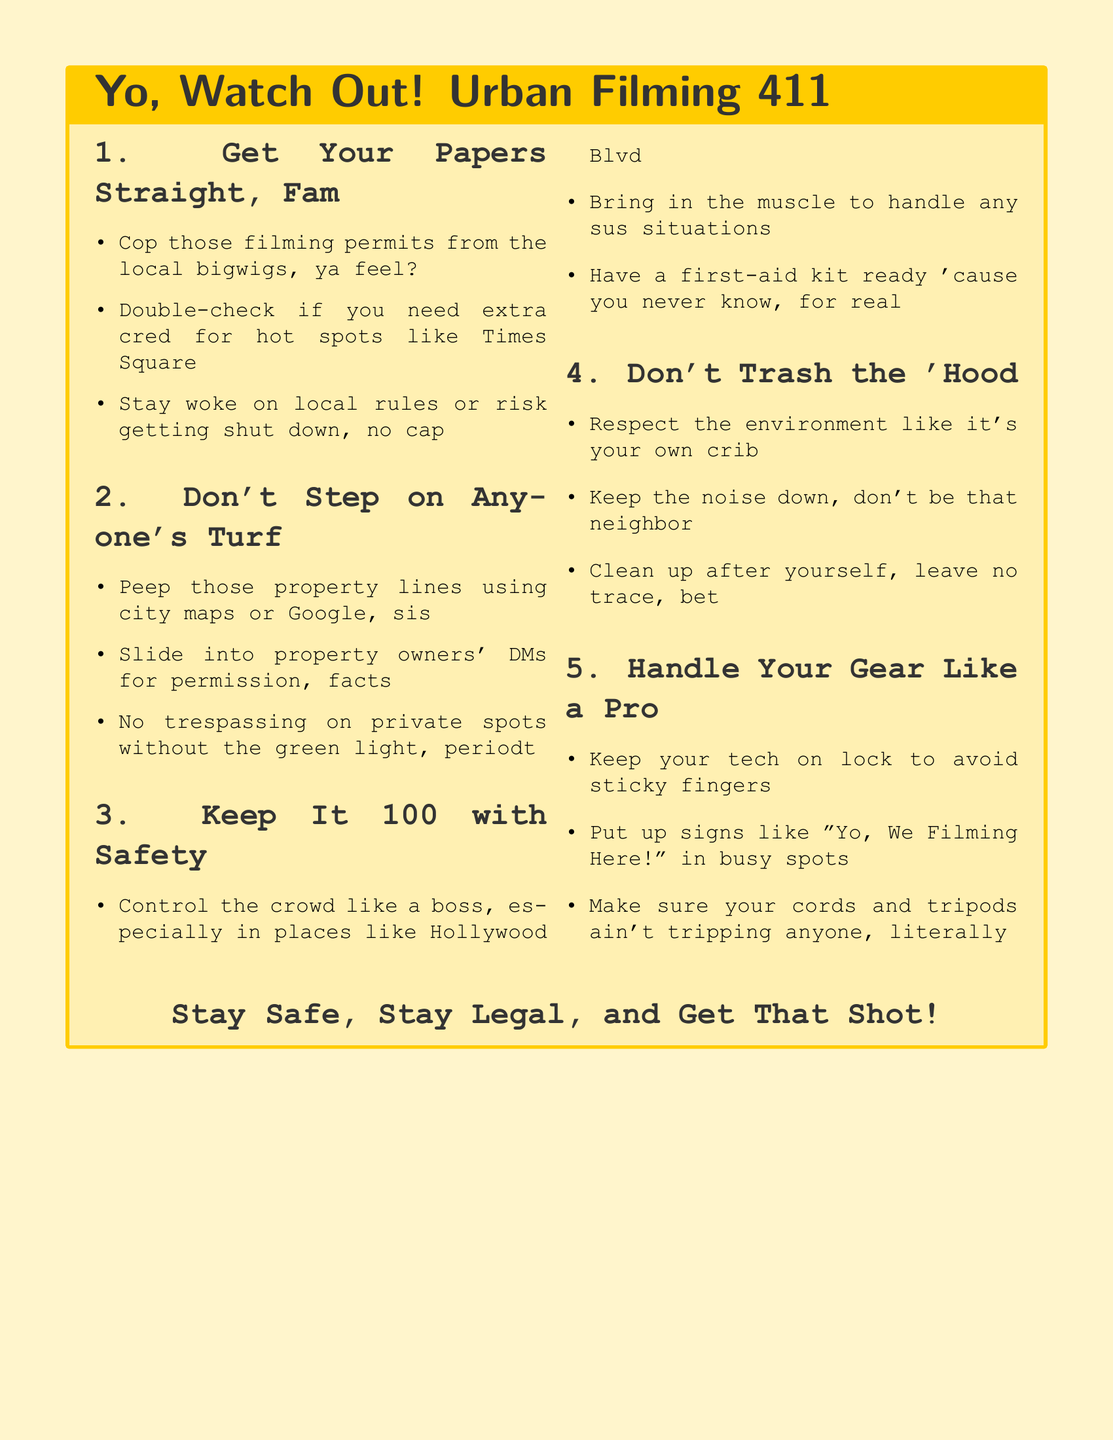What are the permits referred to in the document? The document mentions that obtaining filming permits from local authorities is essential for filming legally.
Answer: Filming permits What should you avoid doing on private property? The document warns against trespassing on private spots without permission from property owners.
Answer: Trespassing What is the first precaution for safety listed? The first safety guideline emphasizes managing crowd control, particularly in busy areas.
Answer: Control the crowd What is emphasized about the environment? The document insists on respecting and maintaining the cleanliness of the filming environment.
Answer: Respect the environment What should you do with your gear? The document advises filmmakers to secure their equipment to prevent theft.
Answer: Keep your tech on lock Which urban location is specifically mentioned? The document highlights Hollywood Blvd as a place requiring careful crowd control.
Answer: Hollywood Blvd How should you communicate filming presence in busy spots? Filmmakers are encouraged to put up signs indicating they are filming.
Answer: "Yo, We Filming Here!" What is advised for handling potential safety issues? The document suggests bringing in security personnel to address any suspicious situations.
Answer: Bring in the muscle 